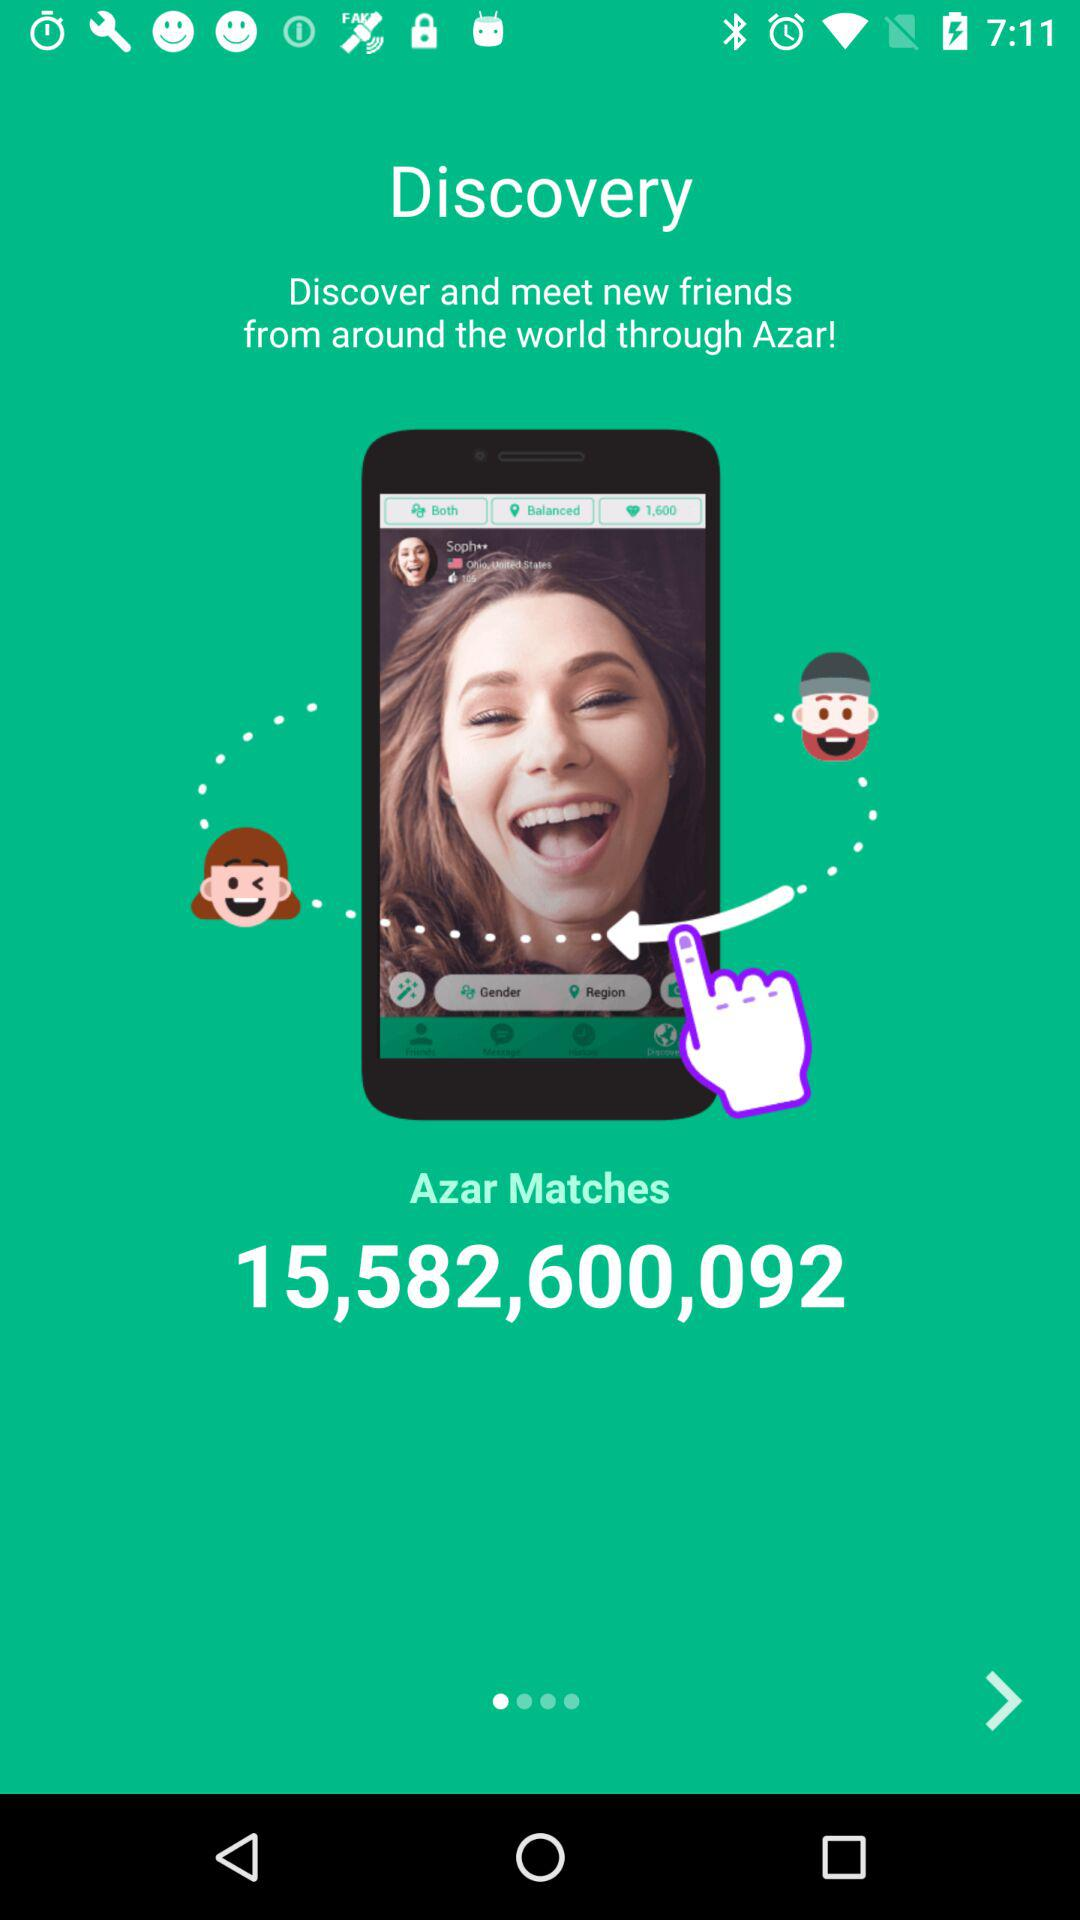What is the total number of matches on "Azar"? The total number of matches on "Azar" is 15,582,600,092. 